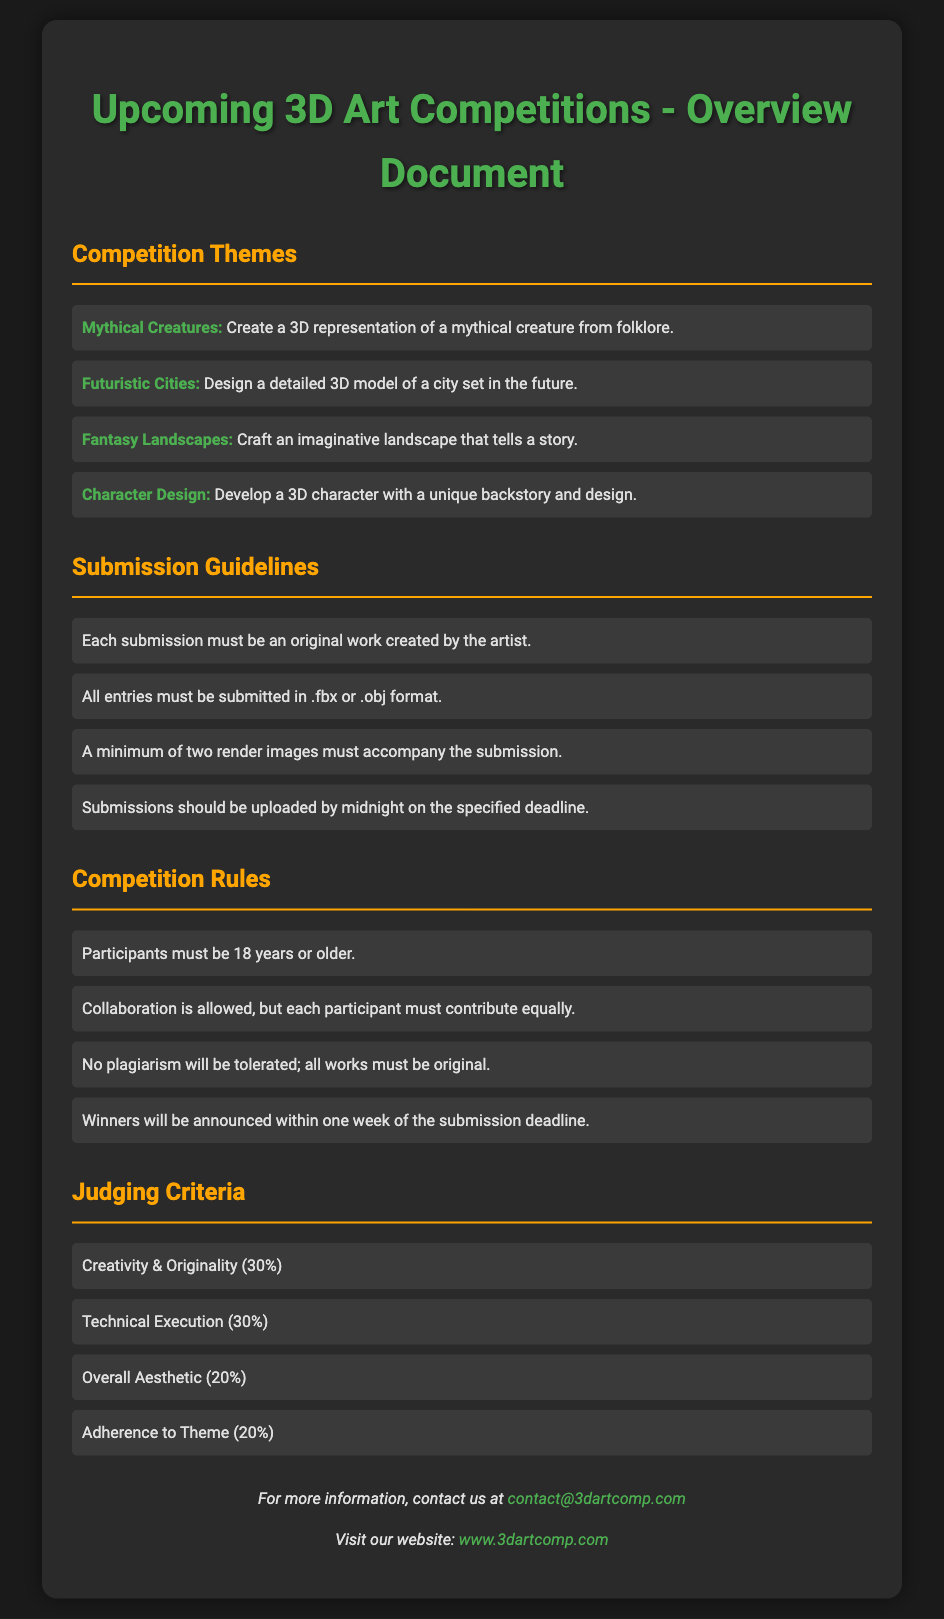What are the competition themes? The document lists several themes for the competitions, including "Mythical Creatures," "Futuristic Cities," "Fantasy Landscapes," and "Character Design."
Answer: Mythical Creatures, Futuristic Cities, Fantasy Landscapes, Character Design What file formats are accepted for submissions? The submission guidelines specify the accepted file formats for entries.
Answer: .fbx or .obj What is the age requirement for participants? The rules state that participants must meet a certain age criterion to enter the competition.
Answer: 18 years or older What percentage of the judging criteria is based on Creativity & Originality? The judging criteria details the weight given to various aspects of the entries, including Creativity & Originality.
Answer: 30% How many render images must accompany each submission? The submission guidelines mention a specific requirement regarding render images for valid submissions.
Answer: Two render images What action is prohibited according to the competition rules? The document outlines specific prohibitions within the competition rules to ensure fairness.
Answer: Plagiarism What will happen after the submission deadline? The rules state what occurs following the submission deadline in terms of announcements.
Answer: Winners will be announced within one week Is collaboration allowed in the competition? The rules clarify the conditions regarding collaboration among participants.
Answer: Yes, collaboration is allowed How can more information be obtained? The document provides contact information for participants seeking additional assistance or details about the competition.
Answer: contact@3dartcomp.com 